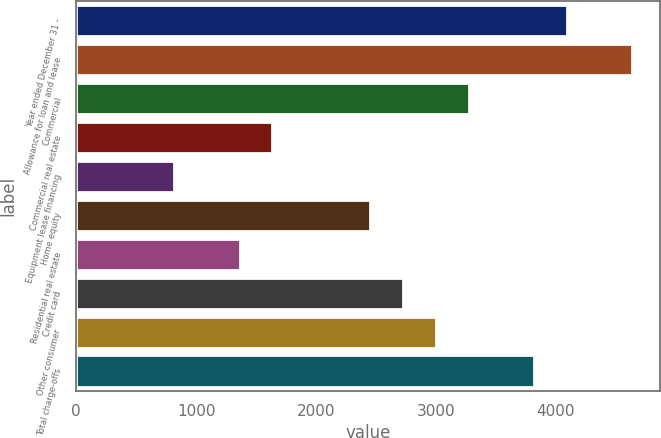Convert chart. <chart><loc_0><loc_0><loc_500><loc_500><bar_chart><fcel>Year ended December 31 -<fcel>Allowance for loan and lease<fcel>Commercial<fcel>Commercial real estate<fcel>Equipment lease financing<fcel>Home equity<fcel>Residential real estate<fcel>Credit card<fcel>Other consumer<fcel>Total charge-offs<nl><fcel>4090.31<fcel>4635.65<fcel>3272.3<fcel>1636.28<fcel>818.27<fcel>2454.29<fcel>1363.61<fcel>2726.96<fcel>2999.63<fcel>3817.64<nl></chart> 